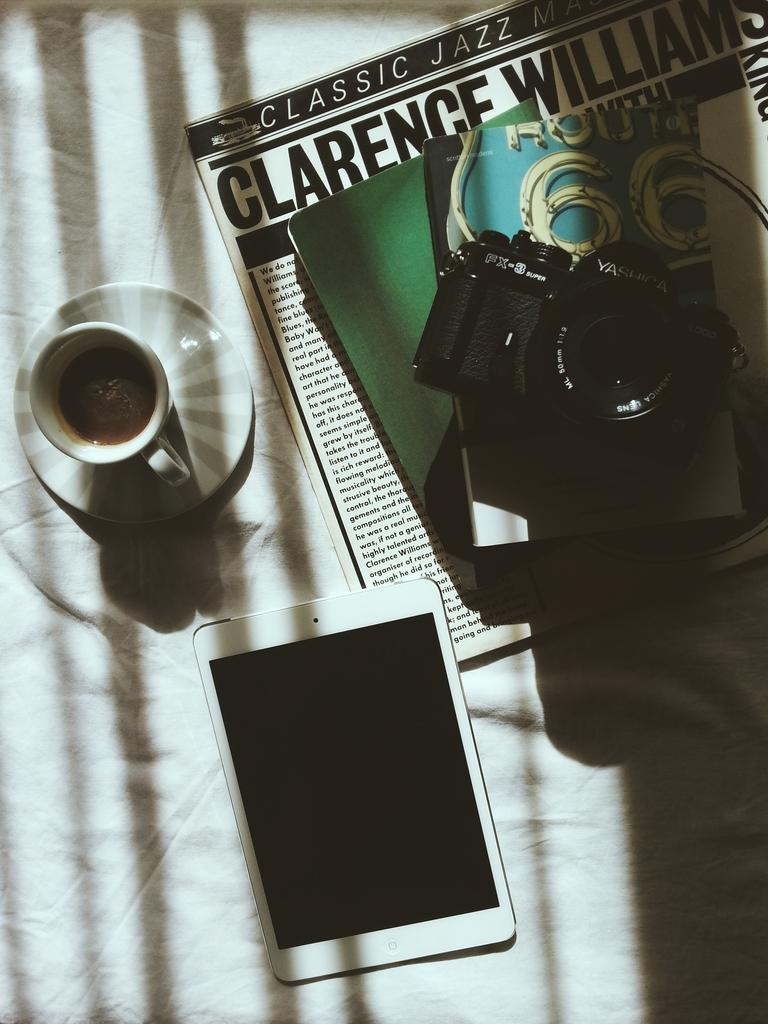What is one of the objects visible in the image? There is a cup in the image. What is another object that can be seen in the image? There is a saucer in the image. What type of device is present in the image? There is a camera in the image. What electronic device is also visible in the image? There is a tablet in the image. Can you describe any other objects present in the image? There are other objects in the image, but their specific details are not mentioned in the provided facts. What type of yak can be seen grazing in the image? There is no yak present in the image; it only contains a cup, saucer, camera, tablet, and other unspecified objects. How many ears does the camera have in the image? The camera does not have ears; it is an electronic device designed to capture images and videos. 